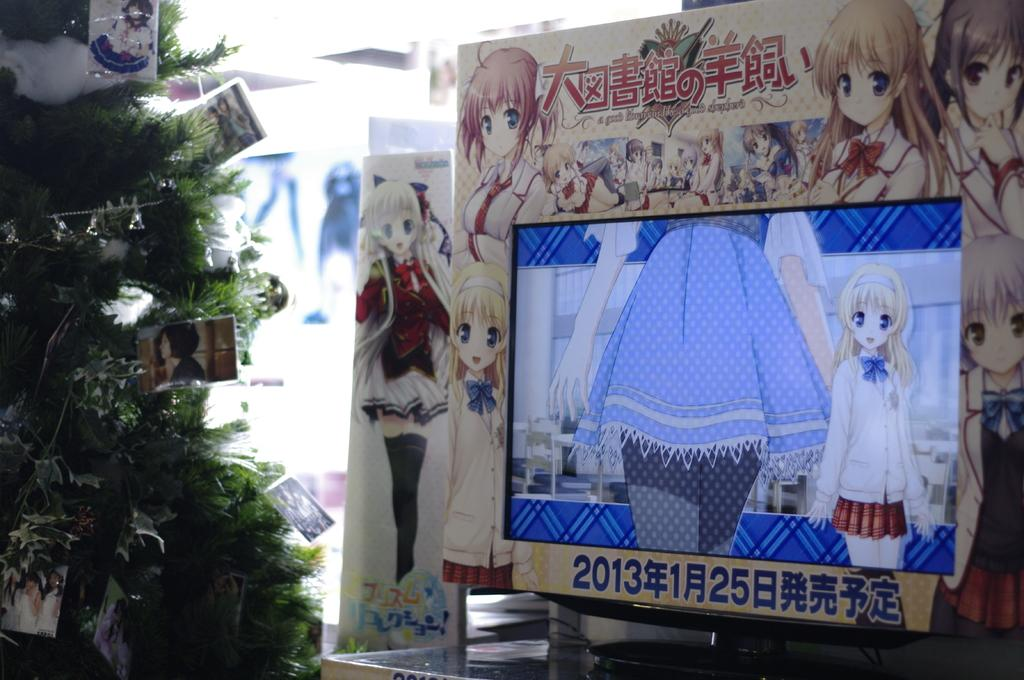What is the main object in the image? There is a board in the image. What electronic device is present in the image? There is a monitor in the image. What type of natural element can be seen on the left side of the image? There is a tree on the left side of the image. What type of visual content can be seen in the image? There are photos and cartoons visible in the image. How do the giants interact with the board in the image? There are no giants present in the image, so it is not possible to answer that question. 